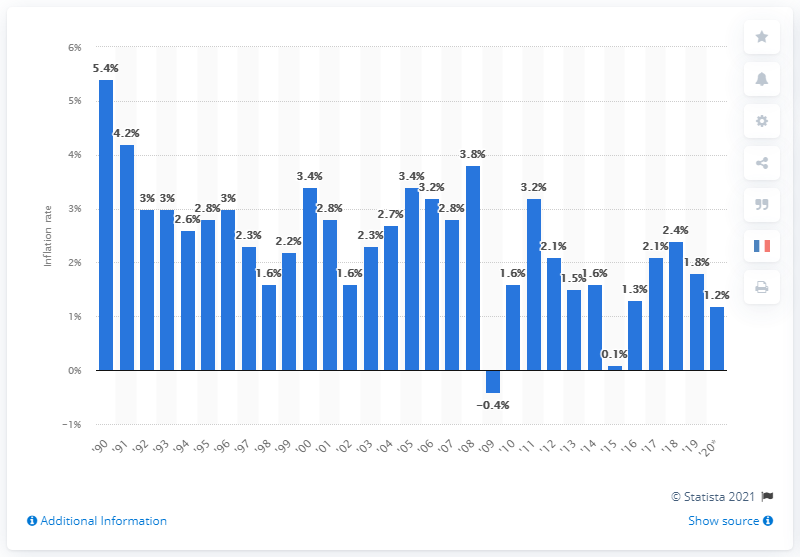Point out several critical features in this image. In the second half of 2020, prices increased by 1.2% compared to the previous year. 